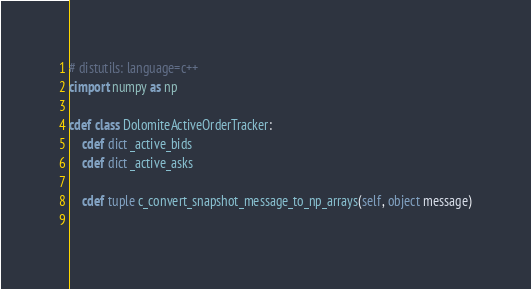<code> <loc_0><loc_0><loc_500><loc_500><_Cython_># distutils: language=c++
cimport numpy as np

cdef class DolomiteActiveOrderTracker:
    cdef dict _active_bids
    cdef dict _active_asks

    cdef tuple c_convert_snapshot_message_to_np_arrays(self, object message)
    </code> 